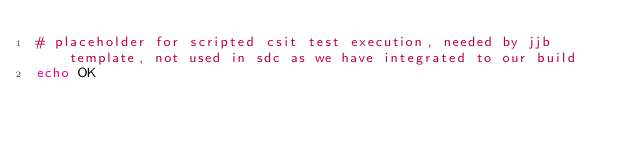Convert code to text. <code><loc_0><loc_0><loc_500><loc_500><_Bash_># placeholder for scripted csit test execution, needed by jjb template, not used in sdc as we have integrated to our build
echo OK</code> 